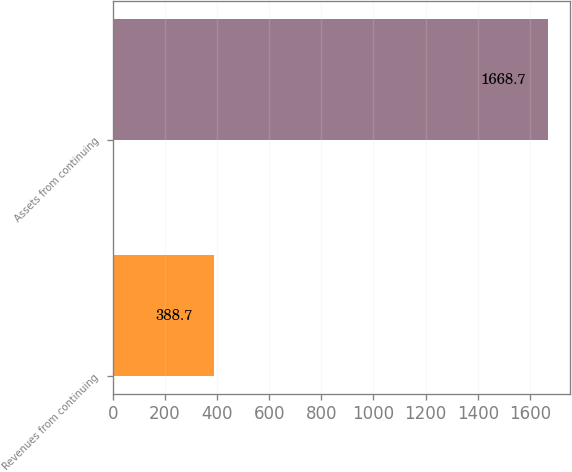<chart> <loc_0><loc_0><loc_500><loc_500><bar_chart><fcel>Revenues from continuing<fcel>Assets from continuing<nl><fcel>388.7<fcel>1668.7<nl></chart> 